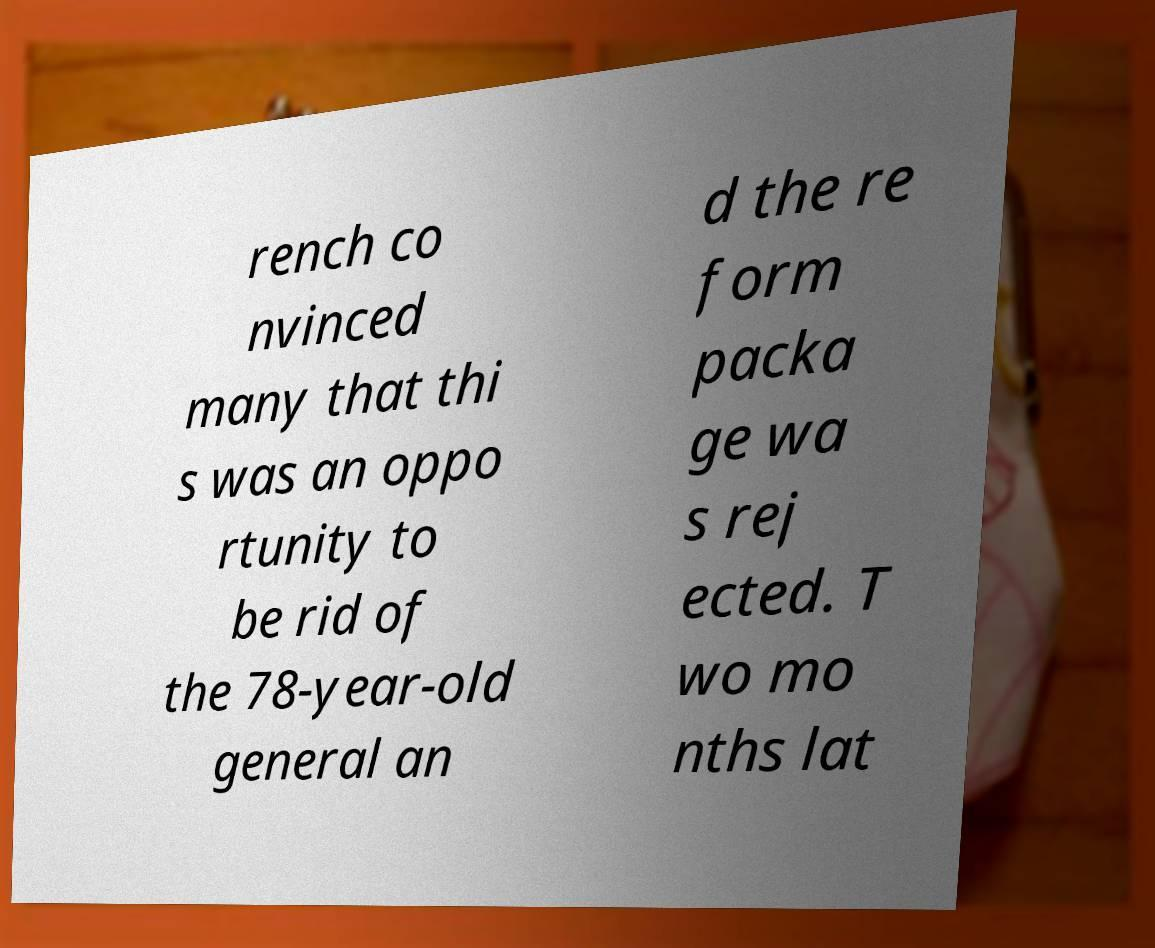I need the written content from this picture converted into text. Can you do that? rench co nvinced many that thi s was an oppo rtunity to be rid of the 78-year-old general an d the re form packa ge wa s rej ected. T wo mo nths lat 